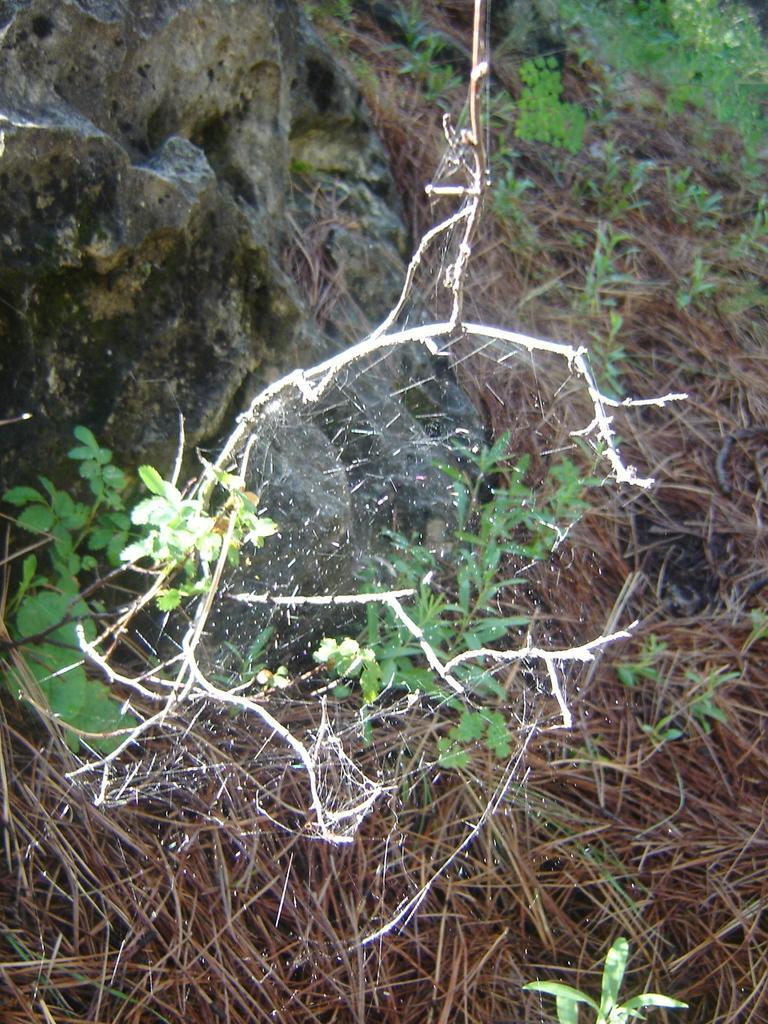Can you describe this image briefly? In this image there is a rock truncated towards the top of the image, there are plants, there are plants truncated towards the left of the image, there are plants truncated towards the bottom of the image, there are plants truncated towards the right of the image, there are dried plants truncated. 